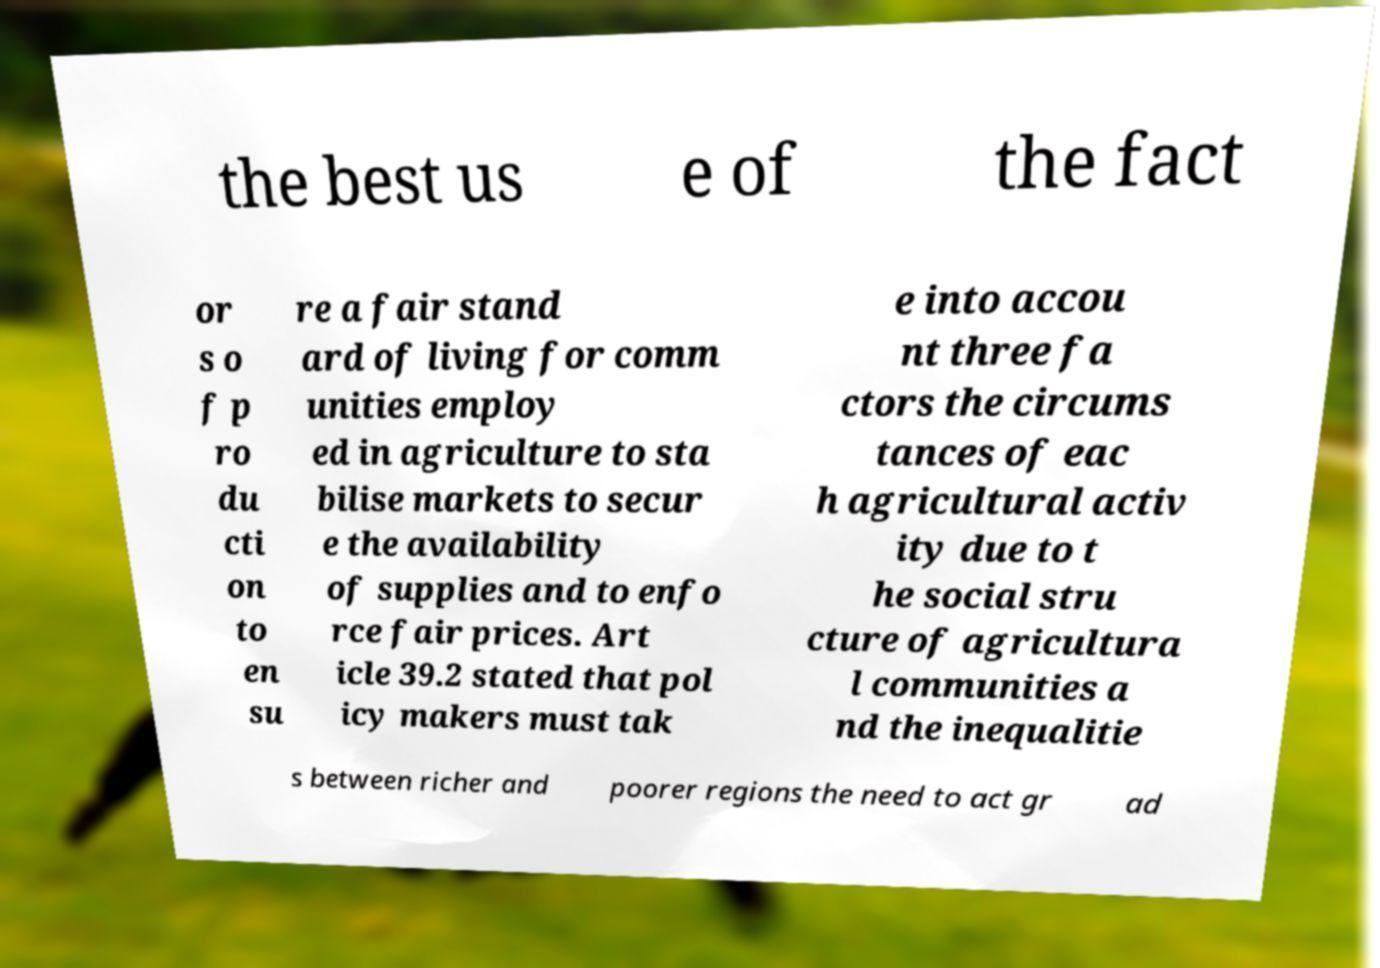Could you assist in decoding the text presented in this image and type it out clearly? the best us e of the fact or s o f p ro du cti on to en su re a fair stand ard of living for comm unities employ ed in agriculture to sta bilise markets to secur e the availability of supplies and to enfo rce fair prices. Art icle 39.2 stated that pol icy makers must tak e into accou nt three fa ctors the circums tances of eac h agricultural activ ity due to t he social stru cture of agricultura l communities a nd the inequalitie s between richer and poorer regions the need to act gr ad 